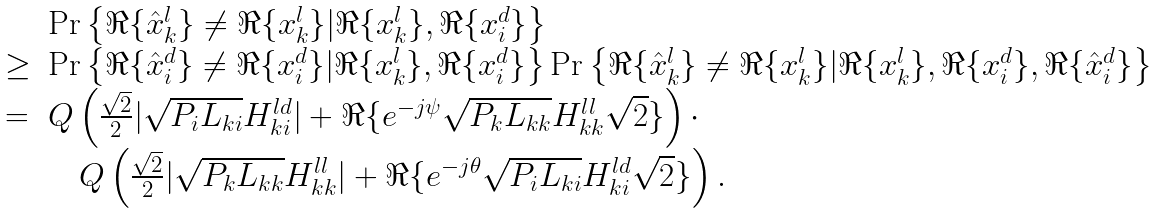Convert formula to latex. <formula><loc_0><loc_0><loc_500><loc_500>\begin{array} { l l } & \Pr \left \{ \Re \{ \hat { x } _ { k } ^ { l } \} \neq \Re \{ x _ { k } ^ { l } \} | \Re \{ x _ { k } ^ { l } \} , \Re \{ x _ { i } ^ { d } \} \right \} \\ \geq & \Pr \left \{ \Re \{ \hat { x } _ { i } ^ { d } \} \neq \Re \{ x _ { i } ^ { d } \} | \Re \{ x _ { k } ^ { l } \} , \Re \{ x _ { i } ^ { d } \} \right \} \Pr \left \{ \Re \{ \hat { x } _ { k } ^ { l } \} \neq \Re \{ x _ { k } ^ { l } \} | \Re \{ x _ { k } ^ { l } \} , \Re \{ x _ { i } ^ { d } \} , \Re \{ \hat { x } _ { i } ^ { d } \} \right \} \\ = & Q \left ( \frac { \sqrt { 2 } } { 2 } | \sqrt { P _ { i } L _ { k i } } H _ { k i } ^ { l d } | + \Re \{ e ^ { - j \psi } \sqrt { P _ { k } L _ { k k } } H _ { k k } ^ { l l } \sqrt { 2 } \} \right ) \cdot \\ & \quad Q \left ( \frac { \sqrt { 2 } } { 2 } | \sqrt { P _ { k } L _ { k k } } H _ { k k } ^ { l l } | + \Re \{ e ^ { - j \theta } \sqrt { P _ { i } L _ { k i } } H _ { k i } ^ { l d } \sqrt { 2 } \} \right ) . \end{array}</formula> 